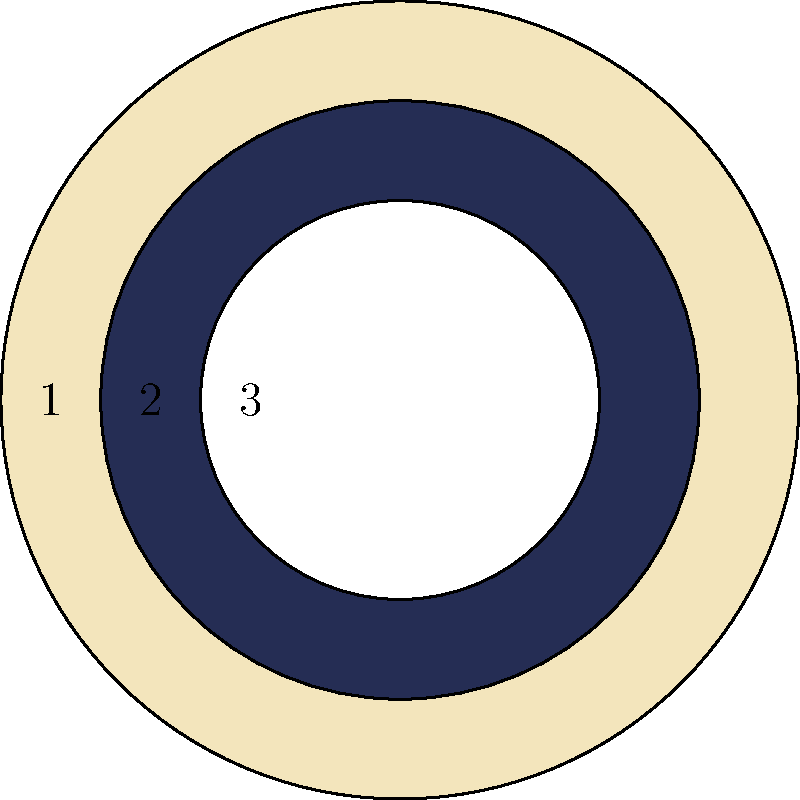In the image above, which numbered circle represents the color of the tzitzit (fringes) that true Israelites are commanded to wear according to Numbers 15:38? To answer this question, we need to follow these steps:

1. Recall the commandment in Numbers 15:38, which states: "Speak unto the children of Israel, and bid them that they make them fringes in the borders of their garments throughout their generations, and that they put upon the fringe of the borders a ribband of blue."

2. Identify the colors in the image:
   Circle 1: Light beige
   Circle 2: Dark blue
   Circle 3: White

3. According to the scripture, the tzitzit should have a "ribband of blue."

4. Among the given options, only circle 2 represents a blue color.

5. Therefore, the blue circle (number 2) corresponds to the color of the tzitzit that true Israelites are commanded to wear.

This understanding is crucial for members of Israel United in Christ, as they emphasize the importance of following biblical commandments, including the wearing of tzitzit with the correct blue color.
Answer: 2 